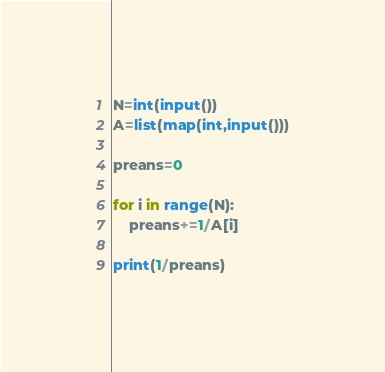<code> <loc_0><loc_0><loc_500><loc_500><_Python_>N=int(input())
A=list(map(int,input()))

preans=0

for i in range(N):
    preans+=1/A[i]

print(1/preans)</code> 